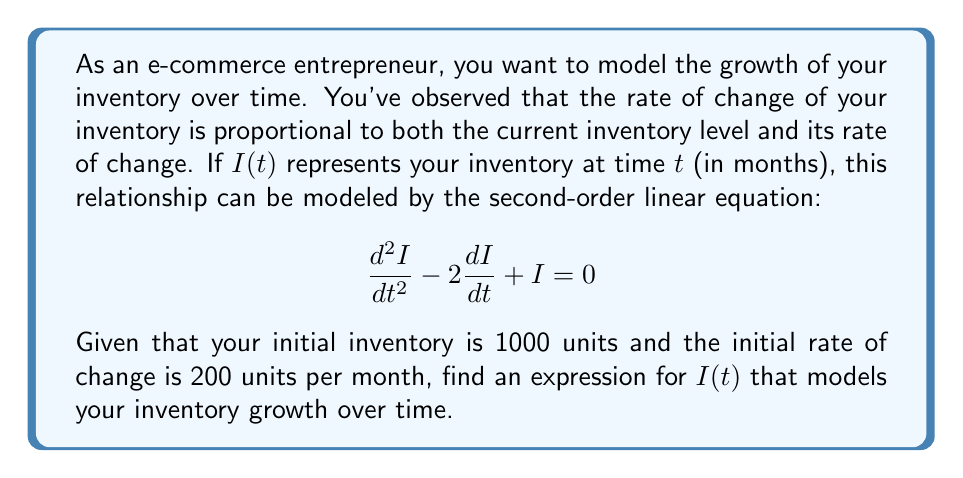What is the answer to this math problem? To solve this second-order linear equation, we'll follow these steps:

1) The characteristic equation for this differential equation is:
   $$r^2 - 2r + 1 = 0$$

2) Solving this quadratic equation:
   $$(r-1)^2 = 0$$
   Therefore, $r = 1$ (repeated root)

3) The general solution for a repeated root is:
   $$I(t) = (c_1 + c_2t)e^t$$

4) Now we'll use the initial conditions to find $c_1$ and $c_2$:
   
   Given: $I(0) = 1000$ and $I'(0) = 200$

5) Using $I(0) = 1000$:
   $$1000 = (c_1 + c_2 \cdot 0)e^0 = c_1$$

6) For $I'(0) = 200$, we first differentiate $I(t)$:
   $$I'(t) = (c_1 + c_2t)e^t + c_2e^t = (c_1 + c_2 + c_2t)e^t$$
   
   Then, $$200 = (c_1 + c_2)e^0 = 1000 + c_2$$
   $$c_2 = -800$$

7) Therefore, the particular solution is:
   $$I(t) = (1000 - 800t)e^t$$

This expression models the inventory growth over time, taking into account the initial conditions and the given differential equation.
Answer: $I(t) = (1000 - 800t)e^t$ 